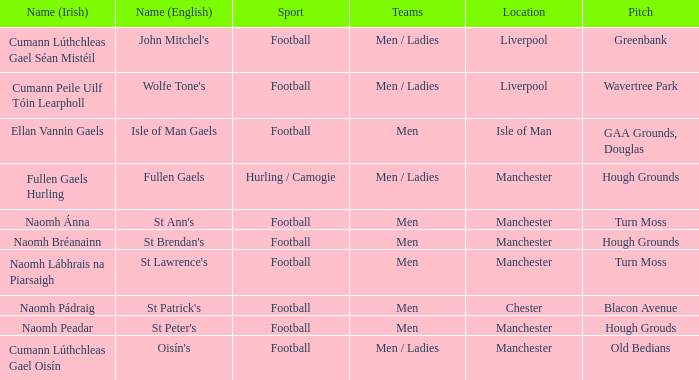What is the location of the pitch on the isle of man? GAA Grounds, Douglas. 